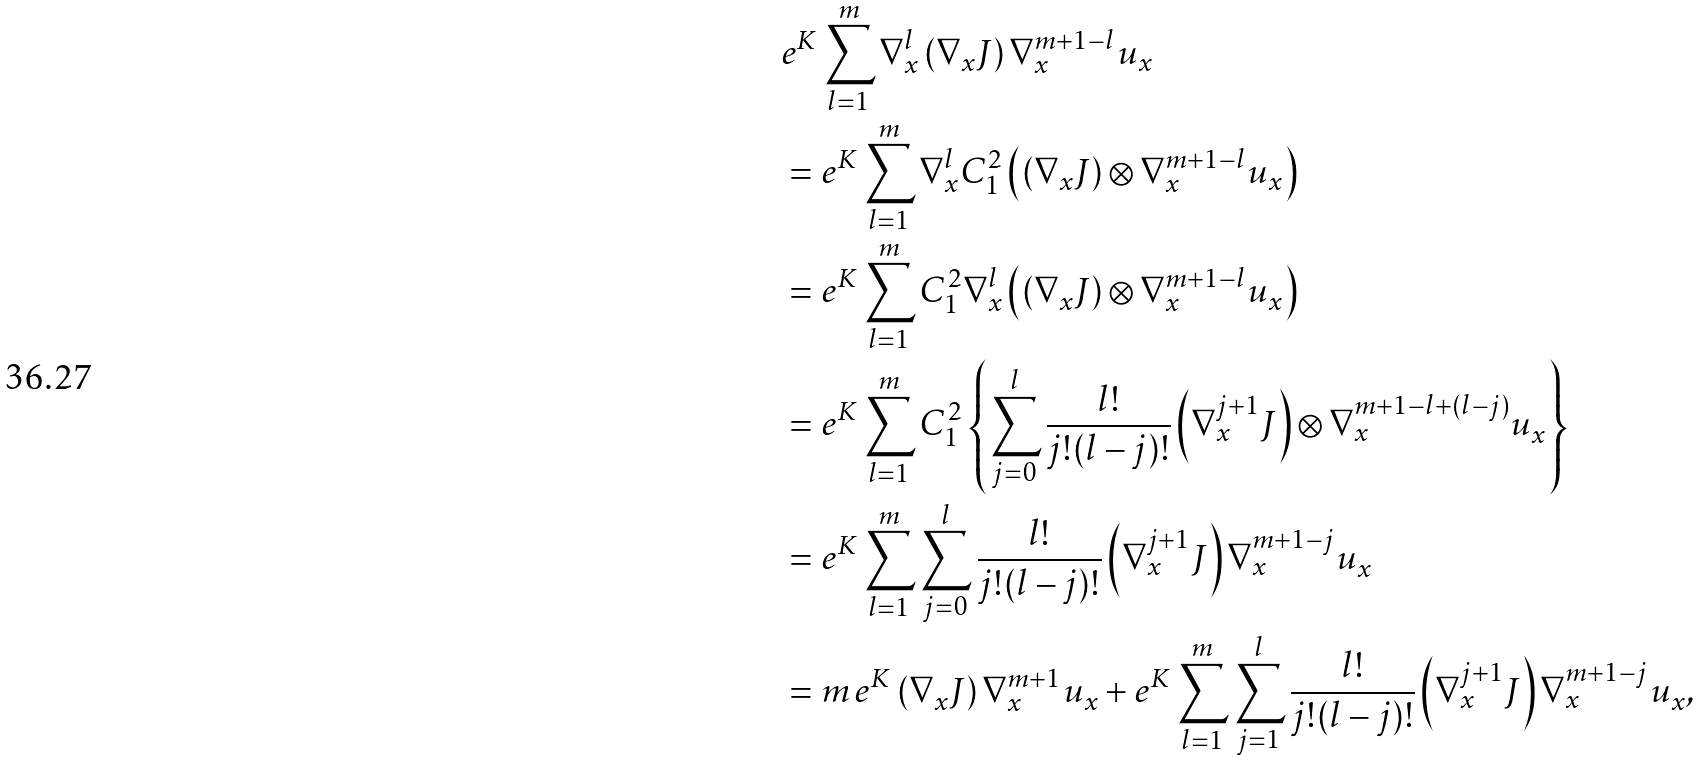Convert formula to latex. <formula><loc_0><loc_0><loc_500><loc_500>& e ^ { K } \sum _ { l = 1 } ^ { m } \nabla _ { x } ^ { l } \left ( \nabla _ { x } J \right ) \nabla _ { x } ^ { m + 1 - l } u _ { x } \\ & = e ^ { K } \sum _ { l = 1 } ^ { m } \nabla _ { x } ^ { l } C _ { 1 } ^ { 2 } \left ( \left ( \nabla _ { x } J \right ) \otimes \nabla _ { x } ^ { m + 1 - l } u _ { x } \right ) \\ & = e ^ { K } \sum _ { l = 1 } ^ { m } C _ { 1 } ^ { 2 } \nabla _ { x } ^ { l } \left ( \left ( \nabla _ { x } J \right ) \otimes \nabla _ { x } ^ { m + 1 - l } u _ { x } \right ) \\ & = e ^ { K } \sum _ { l = 1 } ^ { m } C _ { 1 } ^ { 2 } \left \{ \sum _ { j = 0 } ^ { l } \frac { l ! } { j ! ( l - j ) ! } \left ( \nabla _ { x } ^ { j + 1 } J \right ) \otimes \nabla _ { x } ^ { m + 1 - l + ( l - j ) } u _ { x } \right \} \\ & = e ^ { K } \sum _ { l = 1 } ^ { m } \sum _ { j = 0 } ^ { l } \frac { l ! } { j ! ( l - j ) ! } \left ( \nabla _ { x } ^ { j + 1 } J \right ) \nabla _ { x } ^ { m + 1 - j } u _ { x } \\ & = m \, e ^ { K } \left ( \nabla _ { x } J \right ) \nabla _ { x } ^ { m + 1 } u _ { x } + e ^ { K } \sum _ { l = 1 } ^ { m } \sum _ { j = 1 } ^ { l } \frac { l ! } { j ! ( l - j ) ! } \left ( \nabla _ { x } ^ { j + 1 } J \right ) \nabla _ { x } ^ { m + 1 - j } u _ { x } ,</formula> 